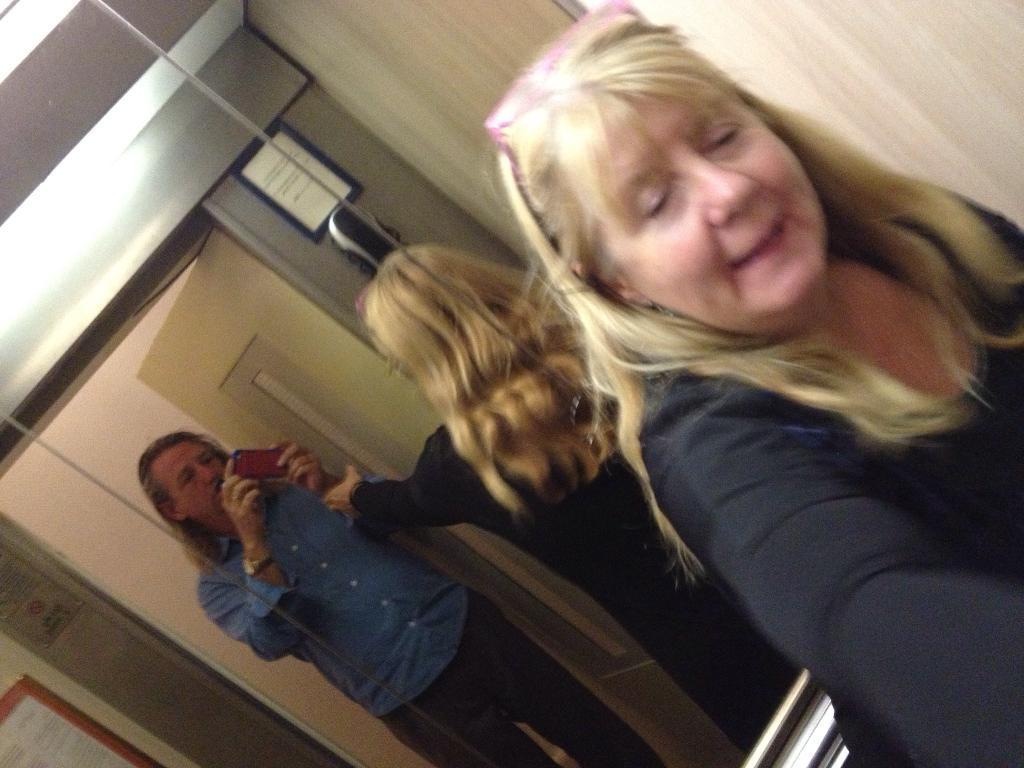Can you describe this image briefly? In this image, we can see a lady wearing glasses and in the background, there is a mirror, through the glass we can see a person holding a mobile and we can see some boards on the wall. At the top, there is a light. 